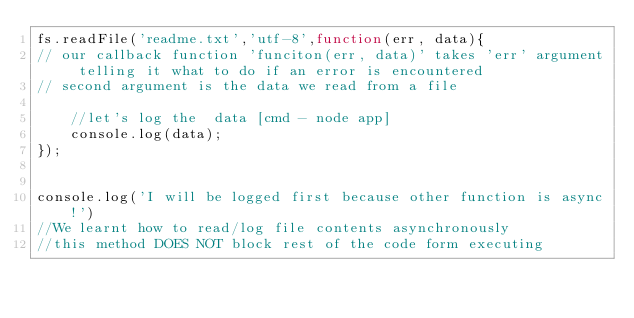Convert code to text. <code><loc_0><loc_0><loc_500><loc_500><_JavaScript_>fs.readFile('readme.txt','utf-8',function(err, data){
// our callback function 'funciton(err, data)' takes 'err' argument telling it what to do if an error is encountered
// second argument is the data we read from a file

	//let's log the  data [cmd - node app]
	console.log(data);
});

			
console.log('I will be logged first because other function is async!')
//We learnt how to read/log file contents asynchronously
//this method DOES NOT block rest of the code form executing

</code> 